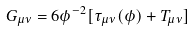<formula> <loc_0><loc_0><loc_500><loc_500>G _ { \mu \nu } = 6 \phi ^ { - 2 } [ \tau _ { \mu \nu } ( \phi ) + T _ { \mu \nu } ]</formula> 